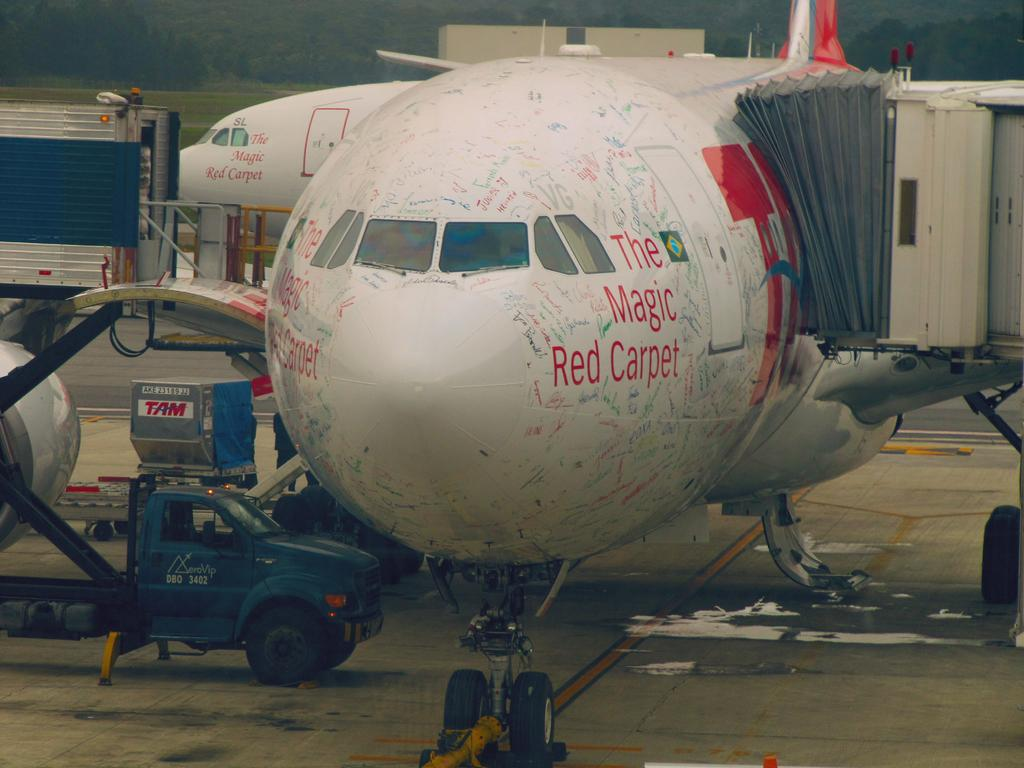<image>
Describe the image concisely. A large jet airplane with the name "The Magic carpet" on the sides is docked at the terminal ready to be loaded. 